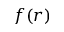Convert formula to latex. <formula><loc_0><loc_0><loc_500><loc_500>f ( r )</formula> 